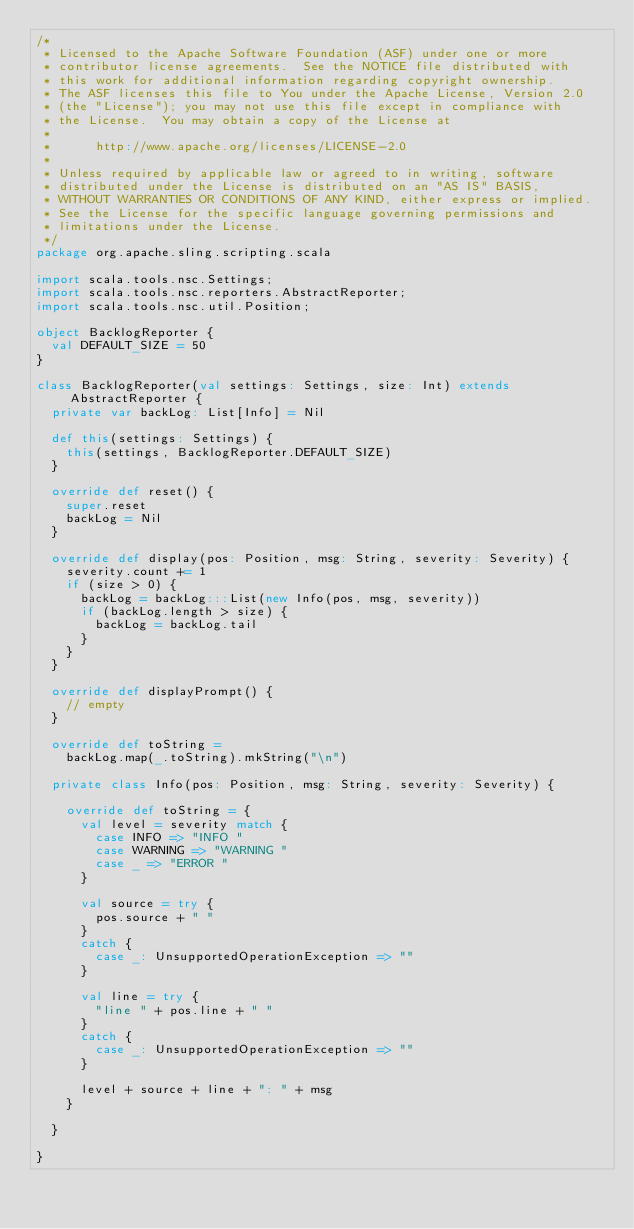<code> <loc_0><loc_0><loc_500><loc_500><_Scala_>/*
 * Licensed to the Apache Software Foundation (ASF) under one or more
 * contributor license agreements.  See the NOTICE file distributed with
 * this work for additional information regarding copyright ownership.
 * The ASF licenses this file to You under the Apache License, Version 2.0
 * (the "License"); you may not use this file except in compliance with
 * the License.  You may obtain a copy of the License at
 *
 *      http://www.apache.org/licenses/LICENSE-2.0
 *
 * Unless required by applicable law or agreed to in writing, software
 * distributed under the License is distributed on an "AS IS" BASIS,
 * WITHOUT WARRANTIES OR CONDITIONS OF ANY KIND, either express or implied.
 * See the License for the specific language governing permissions and
 * limitations under the License.
 */
package org.apache.sling.scripting.scala

import scala.tools.nsc.Settings;
import scala.tools.nsc.reporters.AbstractReporter;
import scala.tools.nsc.util.Position;

object BacklogReporter {
  val DEFAULT_SIZE = 50
}

class BacklogReporter(val settings: Settings, size: Int) extends AbstractReporter {
  private var backLog: List[Info] = Nil
  
  def this(settings: Settings) {
    this(settings, BacklogReporter.DEFAULT_SIZE)
  } 

  override def reset() {
    super.reset
    backLog = Nil
  }

  override def display(pos: Position, msg: String, severity: Severity) {
    severity.count += 1
    if (size > 0) {
      backLog = backLog:::List(new Info(pos, msg, severity))
      if (backLog.length > size) {
        backLog = backLog.tail
      }
    }
  }

  override def displayPrompt() {
    // empty
  }
  
  override def toString = 
    backLog.map(_.toString).mkString("\n")

  private class Info(pos: Position, msg: String, severity: Severity) {
                                 
    override def toString = {
      val level = severity match {
        case INFO => "INFO "
        case WARNING => "WARNING "
        case _ => "ERROR " 
      }
      
      val source = try {
        pos.source + " "
      }
      catch {
        case _: UnsupportedOperationException => ""
      } 
      
      val line = try {
        "line " + pos.line + " "
      }
      catch {
        case _: UnsupportedOperationException => ""
      }
      
      level + source + line + ": " + msg
    }

  }

}
</code> 